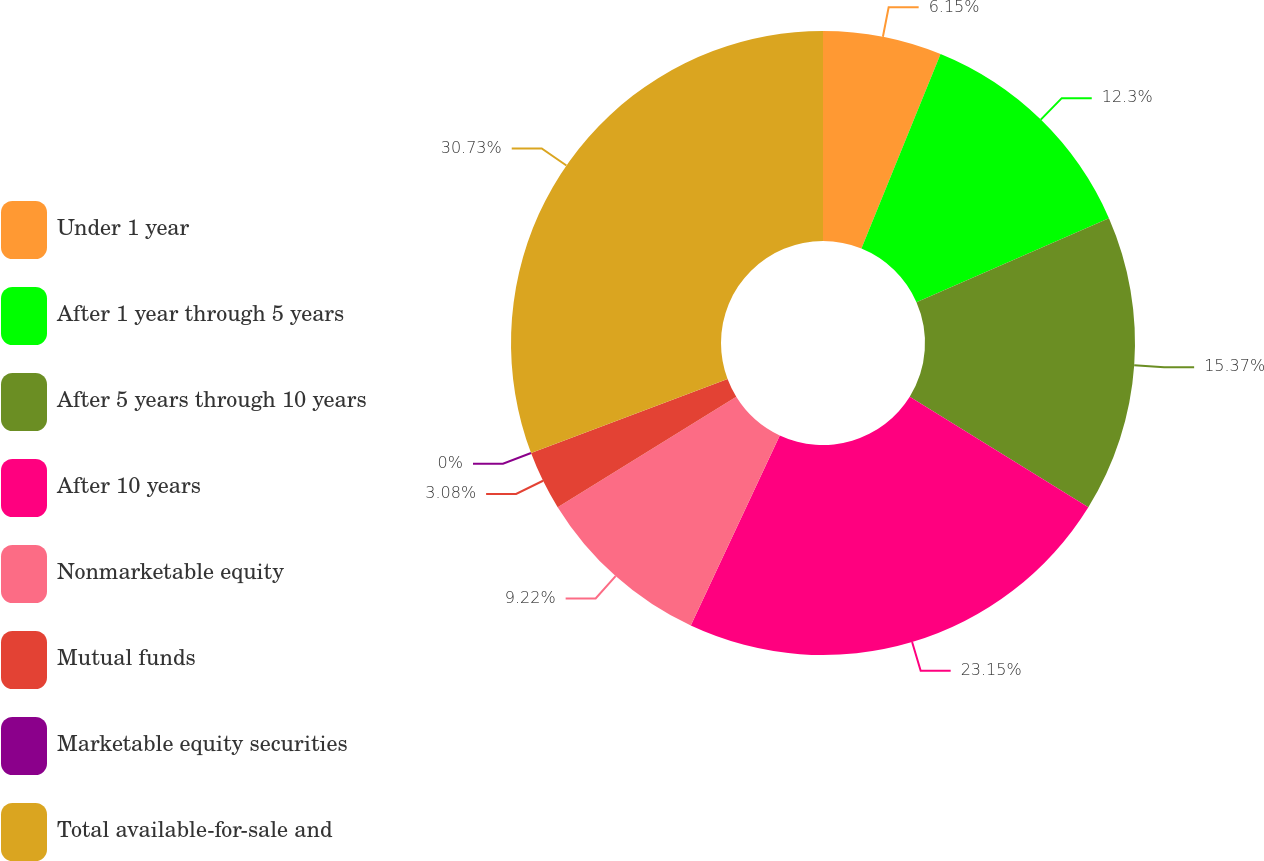Convert chart. <chart><loc_0><loc_0><loc_500><loc_500><pie_chart><fcel>Under 1 year<fcel>After 1 year through 5 years<fcel>After 5 years through 10 years<fcel>After 10 years<fcel>Nonmarketable equity<fcel>Mutual funds<fcel>Marketable equity securities<fcel>Total available-for-sale and<nl><fcel>6.15%<fcel>12.3%<fcel>15.37%<fcel>23.15%<fcel>9.22%<fcel>3.08%<fcel>0.0%<fcel>30.74%<nl></chart> 